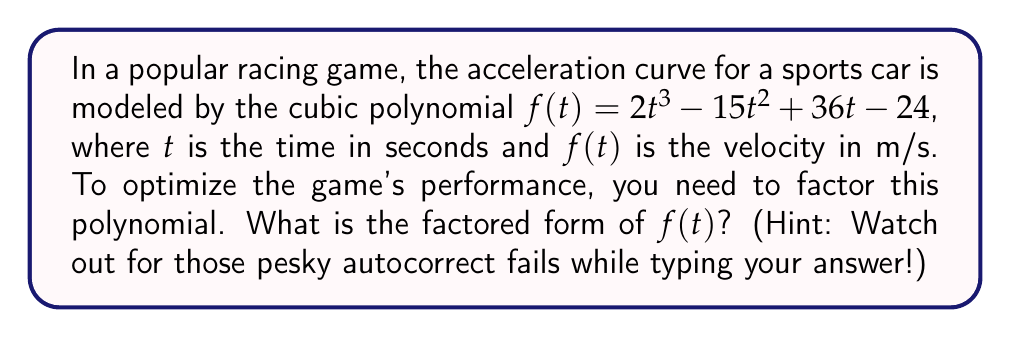Give your solution to this math problem. Let's approach this step-by-step:

1) First, we need to find a factor of the constant term, -24. Let's try (t - 1):

   $f(1) = 2(1)^3 - 15(1)^2 + 36(1) - 24 = 2 - 15 + 36 - 24 = -1$

   Since $f(1) \neq 0$, (t - 1) is not a factor.

2) Let's try (t - 2):

   $f(2) = 2(2)^3 - 15(2)^2 + 36(2) - 24 = 16 - 60 + 72 - 24 = 4$

   Again, $f(2) \neq 0$, so (t - 2) is not a factor.

3) Let's try (t - 3):

   $f(3) = 2(3)^3 - 15(3)^2 + 36(3) - 24 = 54 - 135 + 108 - 24 = 3$

   Once more, $f(3) \neq 0$, so (t - 3) is not a factor.

4) Finally, let's try (t - 4):

   $f(4) = 2(4)^3 - 15(4)^2 + 36(4) - 24 = 128 - 240 + 144 - 24 = 8$

   $f(4) = 0$, so (t - 4) is a factor!

5) Now we can divide $f(t)$ by (t - 4) using polynomial long division:

   $$\frac{2t^3 - 15t^2 + 36t - 24}{t - 4} = 2t^2 + t + 6$$

6) Therefore, $f(t) = (t - 4)(2t^2 + t + 6)$

7) We can factor the quadratic part further:

   $2t^2 + t + 6 = (2t + 3)(t + 2)$

8) Thus, the fully factored form is:

   $f(t) = (t - 4)(2t + 3)(t + 2)$
Answer: $f(t) = (t - 4)(2t + 3)(t + 2)$ 